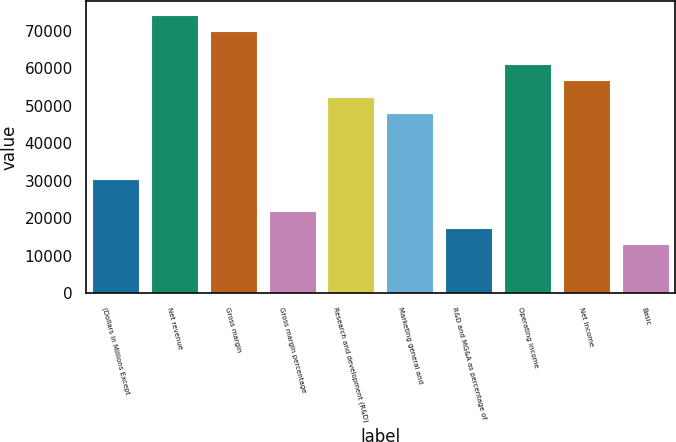<chart> <loc_0><loc_0><loc_500><loc_500><bar_chart><fcel>(Dollars in Millions Except<fcel>Net revenue<fcel>Gross margin<fcel>Gross margin percentage<fcel>Research and development (R&D)<fcel>Marketing general and<fcel>R&D and MG&A as percentage of<fcel>Operating income<fcel>Net income<fcel>Basic<nl><fcel>30536.3<fcel>74158.7<fcel>69796.5<fcel>21811.8<fcel>52347.5<fcel>47985.3<fcel>17449.6<fcel>61072<fcel>56709.8<fcel>13087.4<nl></chart> 